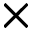<formula> <loc_0><loc_0><loc_500><loc_500>\times</formula> 